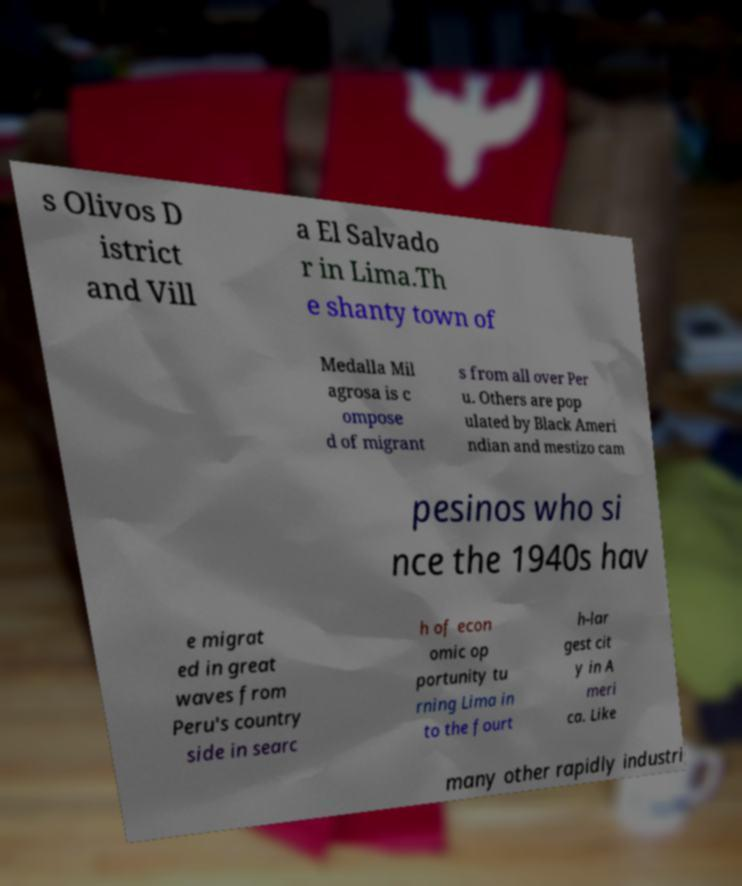Could you assist in decoding the text presented in this image and type it out clearly? s Olivos D istrict and Vill a El Salvado r in Lima.Th e shanty town of Medalla Mil agrosa is c ompose d of migrant s from all over Per u. Others are pop ulated by Black Ameri ndian and mestizo cam pesinos who si nce the 1940s hav e migrat ed in great waves from Peru's country side in searc h of econ omic op portunity tu rning Lima in to the fourt h-lar gest cit y in A meri ca. Like many other rapidly industri 